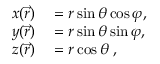<formula> <loc_0><loc_0><loc_500><loc_500>\begin{array} { r l } { x ( \vec { r } ) } & = r \sin \theta \cos \varphi , } \\ { y ( \vec { r } ) } & = r \sin \theta \sin \varphi , } \\ { z ( \vec { r } ) } & = r \cos \theta \, , } \end{array}</formula> 